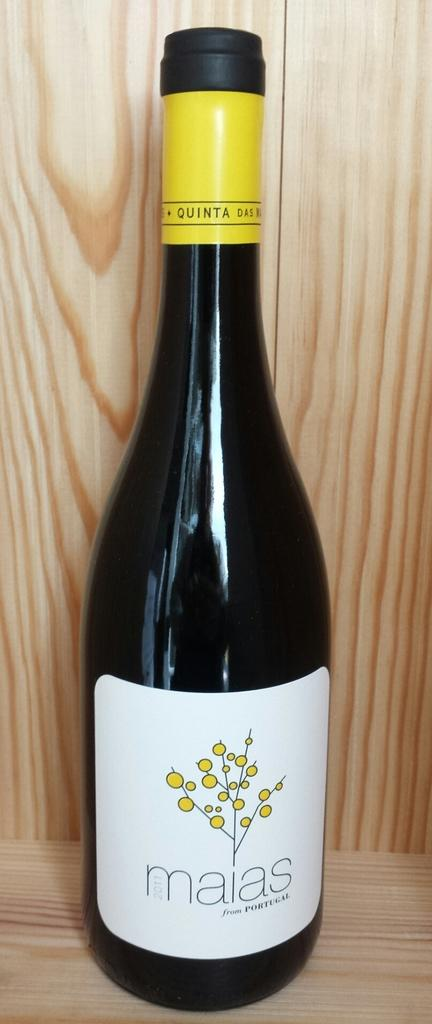<image>
Share a concise interpretation of the image provided. bottle of maias from portugal against wood shelf 